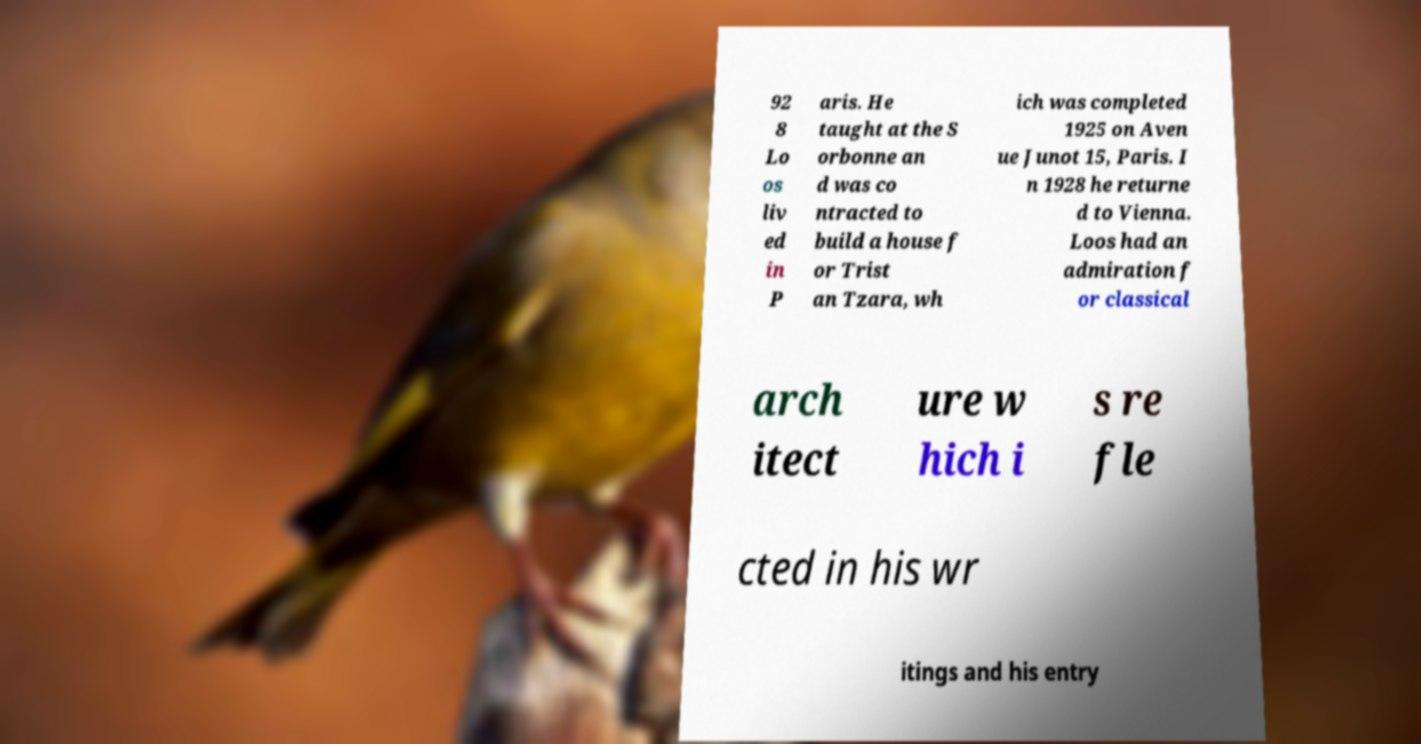Can you accurately transcribe the text from the provided image for me? 92 8 Lo os liv ed in P aris. He taught at the S orbonne an d was co ntracted to build a house f or Trist an Tzara, wh ich was completed 1925 on Aven ue Junot 15, Paris. I n 1928 he returne d to Vienna. Loos had an admiration f or classical arch itect ure w hich i s re fle cted in his wr itings and his entry 